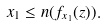<formula> <loc_0><loc_0><loc_500><loc_500>x _ { 1 } \leq n ( f _ { x _ { 1 } } ( z ) ) .</formula> 